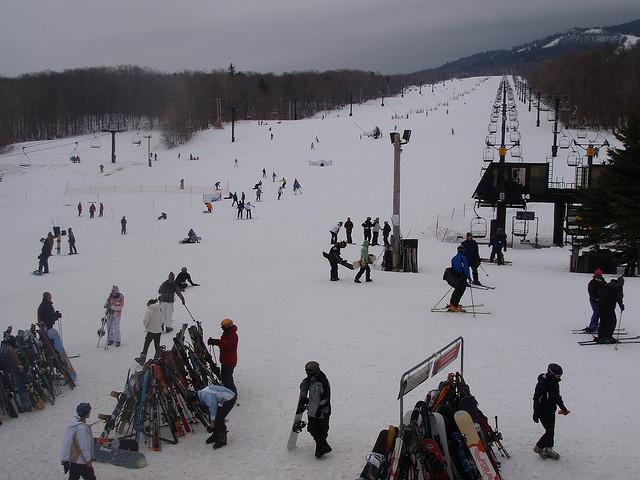How many people are in the picture?
Give a very brief answer. 3. How many red cars are in the picture?
Give a very brief answer. 0. 